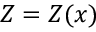<formula> <loc_0><loc_0><loc_500><loc_500>Z = Z ( x )</formula> 